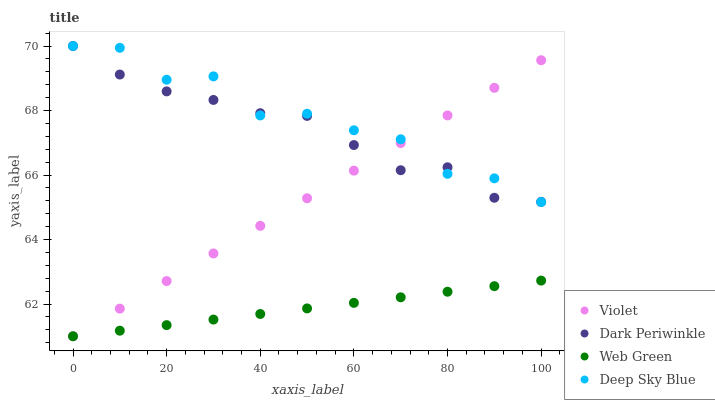Does Web Green have the minimum area under the curve?
Answer yes or no. Yes. Does Deep Sky Blue have the maximum area under the curve?
Answer yes or no. Yes. Does Dark Periwinkle have the minimum area under the curve?
Answer yes or no. No. Does Dark Periwinkle have the maximum area under the curve?
Answer yes or no. No. Is Violet the smoothest?
Answer yes or no. Yes. Is Deep Sky Blue the roughest?
Answer yes or no. Yes. Is Dark Periwinkle the smoothest?
Answer yes or no. No. Is Dark Periwinkle the roughest?
Answer yes or no. No. Does Web Green have the lowest value?
Answer yes or no. Yes. Does Dark Periwinkle have the lowest value?
Answer yes or no. No. Does Dark Periwinkle have the highest value?
Answer yes or no. Yes. Does Web Green have the highest value?
Answer yes or no. No. Is Web Green less than Dark Periwinkle?
Answer yes or no. Yes. Is Deep Sky Blue greater than Web Green?
Answer yes or no. Yes. Does Violet intersect Dark Periwinkle?
Answer yes or no. Yes. Is Violet less than Dark Periwinkle?
Answer yes or no. No. Is Violet greater than Dark Periwinkle?
Answer yes or no. No. Does Web Green intersect Dark Periwinkle?
Answer yes or no. No. 